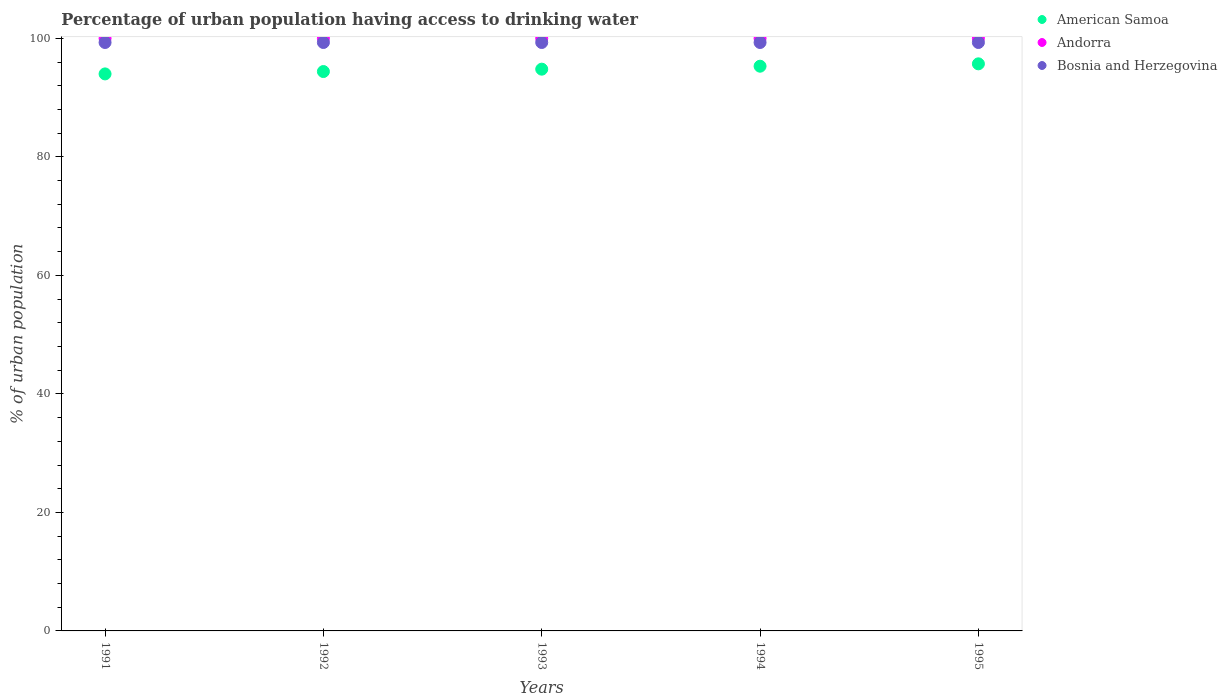Is the number of dotlines equal to the number of legend labels?
Your answer should be very brief. Yes. What is the percentage of urban population having access to drinking water in American Samoa in 1994?
Your answer should be compact. 95.3. Across all years, what is the maximum percentage of urban population having access to drinking water in Andorra?
Provide a short and direct response. 100. Across all years, what is the minimum percentage of urban population having access to drinking water in American Samoa?
Offer a terse response. 94. What is the total percentage of urban population having access to drinking water in American Samoa in the graph?
Keep it short and to the point. 474.2. What is the difference between the percentage of urban population having access to drinking water in Bosnia and Herzegovina in 1994 and the percentage of urban population having access to drinking water in American Samoa in 1995?
Offer a very short reply. 3.6. What is the average percentage of urban population having access to drinking water in Bosnia and Herzegovina per year?
Your answer should be compact. 99.3. In the year 1991, what is the difference between the percentage of urban population having access to drinking water in Andorra and percentage of urban population having access to drinking water in Bosnia and Herzegovina?
Your answer should be compact. 0.7. In how many years, is the percentage of urban population having access to drinking water in Bosnia and Herzegovina greater than 12 %?
Make the answer very short. 5. What is the ratio of the percentage of urban population having access to drinking water in Bosnia and Herzegovina in 1993 to that in 1995?
Make the answer very short. 1. What is the difference between the highest and the second highest percentage of urban population having access to drinking water in Andorra?
Make the answer very short. 0. In how many years, is the percentage of urban population having access to drinking water in Bosnia and Herzegovina greater than the average percentage of urban population having access to drinking water in Bosnia and Herzegovina taken over all years?
Offer a very short reply. 0. Is the sum of the percentage of urban population having access to drinking water in American Samoa in 1991 and 1995 greater than the maximum percentage of urban population having access to drinking water in Bosnia and Herzegovina across all years?
Give a very brief answer. Yes. Is it the case that in every year, the sum of the percentage of urban population having access to drinking water in Bosnia and Herzegovina and percentage of urban population having access to drinking water in American Samoa  is greater than the percentage of urban population having access to drinking water in Andorra?
Your answer should be compact. Yes. Does the percentage of urban population having access to drinking water in Andorra monotonically increase over the years?
Your response must be concise. No. Is the percentage of urban population having access to drinking water in Bosnia and Herzegovina strictly greater than the percentage of urban population having access to drinking water in Andorra over the years?
Your answer should be compact. No. Is the percentage of urban population having access to drinking water in American Samoa strictly less than the percentage of urban population having access to drinking water in Bosnia and Herzegovina over the years?
Keep it short and to the point. Yes. Are the values on the major ticks of Y-axis written in scientific E-notation?
Offer a very short reply. No. Does the graph contain grids?
Offer a terse response. No. How are the legend labels stacked?
Offer a very short reply. Vertical. What is the title of the graph?
Offer a very short reply. Percentage of urban population having access to drinking water. What is the label or title of the X-axis?
Your response must be concise. Years. What is the label or title of the Y-axis?
Ensure brevity in your answer.  % of urban population. What is the % of urban population in American Samoa in 1991?
Provide a short and direct response. 94. What is the % of urban population of Bosnia and Herzegovina in 1991?
Provide a short and direct response. 99.3. What is the % of urban population of American Samoa in 1992?
Your response must be concise. 94.4. What is the % of urban population of Andorra in 1992?
Your answer should be compact. 100. What is the % of urban population of Bosnia and Herzegovina in 1992?
Give a very brief answer. 99.3. What is the % of urban population in American Samoa in 1993?
Your answer should be compact. 94.8. What is the % of urban population of Bosnia and Herzegovina in 1993?
Ensure brevity in your answer.  99.3. What is the % of urban population of American Samoa in 1994?
Make the answer very short. 95.3. What is the % of urban population in Andorra in 1994?
Give a very brief answer. 100. What is the % of urban population in Bosnia and Herzegovina in 1994?
Provide a short and direct response. 99.3. What is the % of urban population in American Samoa in 1995?
Keep it short and to the point. 95.7. What is the % of urban population in Bosnia and Herzegovina in 1995?
Your answer should be very brief. 99.3. Across all years, what is the maximum % of urban population in American Samoa?
Offer a very short reply. 95.7. Across all years, what is the maximum % of urban population of Bosnia and Herzegovina?
Your answer should be compact. 99.3. Across all years, what is the minimum % of urban population in American Samoa?
Provide a short and direct response. 94. Across all years, what is the minimum % of urban population in Andorra?
Make the answer very short. 100. Across all years, what is the minimum % of urban population of Bosnia and Herzegovina?
Make the answer very short. 99.3. What is the total % of urban population of American Samoa in the graph?
Ensure brevity in your answer.  474.2. What is the total % of urban population in Bosnia and Herzegovina in the graph?
Provide a short and direct response. 496.5. What is the difference between the % of urban population of American Samoa in 1991 and that in 1992?
Your response must be concise. -0.4. What is the difference between the % of urban population of Bosnia and Herzegovina in 1991 and that in 1992?
Your answer should be compact. 0. What is the difference between the % of urban population in American Samoa in 1991 and that in 1993?
Your response must be concise. -0.8. What is the difference between the % of urban population in American Samoa in 1991 and that in 1994?
Offer a terse response. -1.3. What is the difference between the % of urban population in Andorra in 1991 and that in 1994?
Ensure brevity in your answer.  0. What is the difference between the % of urban population of Bosnia and Herzegovina in 1991 and that in 1994?
Your response must be concise. 0. What is the difference between the % of urban population in American Samoa in 1991 and that in 1995?
Offer a very short reply. -1.7. What is the difference between the % of urban population in Andorra in 1991 and that in 1995?
Offer a very short reply. 0. What is the difference between the % of urban population in American Samoa in 1992 and that in 1994?
Ensure brevity in your answer.  -0.9. What is the difference between the % of urban population of Bosnia and Herzegovina in 1992 and that in 1994?
Keep it short and to the point. 0. What is the difference between the % of urban population in Andorra in 1993 and that in 1994?
Your answer should be very brief. 0. What is the difference between the % of urban population in Bosnia and Herzegovina in 1993 and that in 1994?
Keep it short and to the point. 0. What is the difference between the % of urban population of American Samoa in 1993 and that in 1995?
Keep it short and to the point. -0.9. What is the difference between the % of urban population in Andorra in 1993 and that in 1995?
Your answer should be very brief. 0. What is the difference between the % of urban population in American Samoa in 1994 and that in 1995?
Ensure brevity in your answer.  -0.4. What is the difference between the % of urban population of American Samoa in 1991 and the % of urban population of Andorra in 1992?
Give a very brief answer. -6. What is the difference between the % of urban population in Andorra in 1991 and the % of urban population in Bosnia and Herzegovina in 1992?
Make the answer very short. 0.7. What is the difference between the % of urban population of American Samoa in 1991 and the % of urban population of Andorra in 1993?
Keep it short and to the point. -6. What is the difference between the % of urban population in American Samoa in 1991 and the % of urban population in Bosnia and Herzegovina in 1993?
Your answer should be compact. -5.3. What is the difference between the % of urban population of American Samoa in 1991 and the % of urban population of Andorra in 1995?
Your answer should be very brief. -6. What is the difference between the % of urban population of American Samoa in 1991 and the % of urban population of Bosnia and Herzegovina in 1995?
Your answer should be compact. -5.3. What is the difference between the % of urban population in American Samoa in 1992 and the % of urban population in Andorra in 1993?
Give a very brief answer. -5.6. What is the difference between the % of urban population of American Samoa in 1992 and the % of urban population of Bosnia and Herzegovina in 1993?
Provide a succinct answer. -4.9. What is the difference between the % of urban population in Andorra in 1992 and the % of urban population in Bosnia and Herzegovina in 1993?
Keep it short and to the point. 0.7. What is the difference between the % of urban population of American Samoa in 1992 and the % of urban population of Andorra in 1994?
Offer a very short reply. -5.6. What is the difference between the % of urban population of Andorra in 1993 and the % of urban population of Bosnia and Herzegovina in 1994?
Your answer should be compact. 0.7. What is the difference between the % of urban population of American Samoa in 1993 and the % of urban population of Andorra in 1995?
Your response must be concise. -5.2. What is the difference between the % of urban population of American Samoa in 1993 and the % of urban population of Bosnia and Herzegovina in 1995?
Your answer should be very brief. -4.5. What is the difference between the % of urban population in Andorra in 1993 and the % of urban population in Bosnia and Herzegovina in 1995?
Your answer should be compact. 0.7. What is the difference between the % of urban population of American Samoa in 1994 and the % of urban population of Andorra in 1995?
Keep it short and to the point. -4.7. What is the difference between the % of urban population of Andorra in 1994 and the % of urban population of Bosnia and Herzegovina in 1995?
Give a very brief answer. 0.7. What is the average % of urban population in American Samoa per year?
Your response must be concise. 94.84. What is the average % of urban population of Andorra per year?
Offer a very short reply. 100. What is the average % of urban population of Bosnia and Herzegovina per year?
Give a very brief answer. 99.3. In the year 1991, what is the difference between the % of urban population of American Samoa and % of urban population of Bosnia and Herzegovina?
Provide a succinct answer. -5.3. In the year 1992, what is the difference between the % of urban population in Andorra and % of urban population in Bosnia and Herzegovina?
Give a very brief answer. 0.7. In the year 1994, what is the difference between the % of urban population in American Samoa and % of urban population in Andorra?
Make the answer very short. -4.7. In the year 1994, what is the difference between the % of urban population in American Samoa and % of urban population in Bosnia and Herzegovina?
Offer a terse response. -4. In the year 1995, what is the difference between the % of urban population of American Samoa and % of urban population of Bosnia and Herzegovina?
Your response must be concise. -3.6. In the year 1995, what is the difference between the % of urban population in Andorra and % of urban population in Bosnia and Herzegovina?
Offer a very short reply. 0.7. What is the ratio of the % of urban population in American Samoa in 1991 to that in 1992?
Offer a terse response. 1. What is the ratio of the % of urban population of American Samoa in 1991 to that in 1993?
Ensure brevity in your answer.  0.99. What is the ratio of the % of urban population of American Samoa in 1991 to that in 1994?
Give a very brief answer. 0.99. What is the ratio of the % of urban population of Bosnia and Herzegovina in 1991 to that in 1994?
Your answer should be compact. 1. What is the ratio of the % of urban population in American Samoa in 1991 to that in 1995?
Ensure brevity in your answer.  0.98. What is the ratio of the % of urban population of Andorra in 1991 to that in 1995?
Give a very brief answer. 1. What is the ratio of the % of urban population in American Samoa in 1992 to that in 1993?
Give a very brief answer. 1. What is the ratio of the % of urban population of American Samoa in 1992 to that in 1994?
Ensure brevity in your answer.  0.99. What is the ratio of the % of urban population in American Samoa in 1992 to that in 1995?
Your answer should be compact. 0.99. What is the ratio of the % of urban population of Andorra in 1992 to that in 1995?
Make the answer very short. 1. What is the ratio of the % of urban population in American Samoa in 1993 to that in 1994?
Give a very brief answer. 0.99. What is the ratio of the % of urban population of Bosnia and Herzegovina in 1993 to that in 1994?
Your answer should be very brief. 1. What is the ratio of the % of urban population in American Samoa in 1993 to that in 1995?
Offer a very short reply. 0.99. What is the ratio of the % of urban population in Bosnia and Herzegovina in 1993 to that in 1995?
Offer a very short reply. 1. What is the ratio of the % of urban population in Andorra in 1994 to that in 1995?
Make the answer very short. 1. What is the difference between the highest and the lowest % of urban population in Bosnia and Herzegovina?
Your answer should be very brief. 0. 